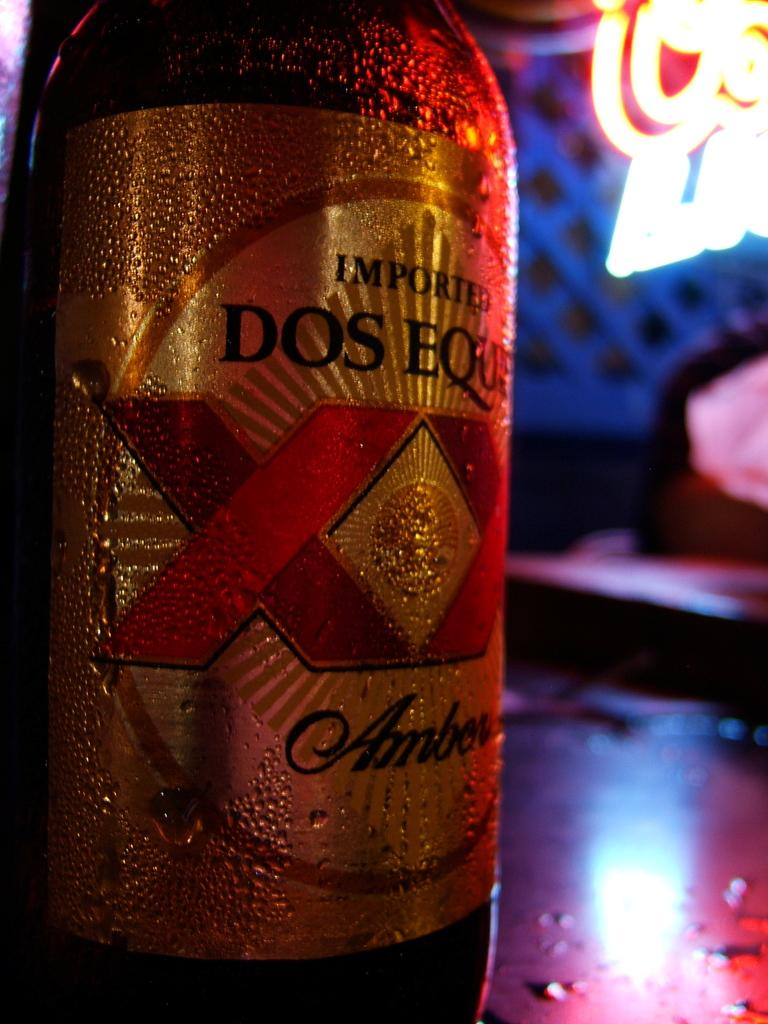<image>
Write a terse but informative summary of the picture. The cold, imported Dos Equs Amber perspired in the heat. 